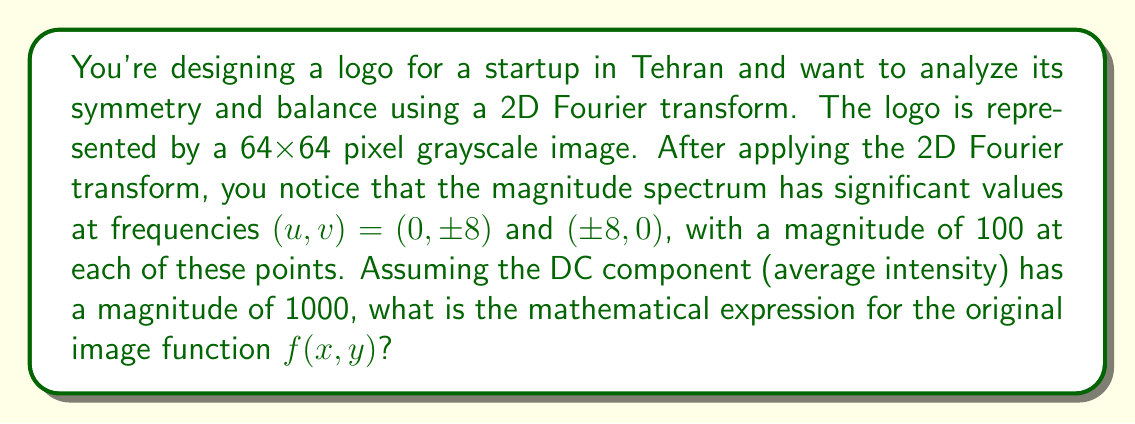Can you answer this question? To solve this problem, we need to work backwards from the Fourier transform to the original image function. Let's follow these steps:

1) The 2D Fourier transform pair is given by:

   $$F(u,v) = \sum_{x=0}^{M-1} \sum_{y=0}^{N-1} f(x,y) e^{-j2\pi(ux/M + vy/N)}$$
   $$f(x,y) = \frac{1}{MN} \sum_{u=0}^{M-1} \sum_{v=0}^{N-1} F(u,v) e^{j2\pi(ux/M + vy/N)}$$

   where M and N are the image dimensions (both 64 in this case).

2) From the given information, we know that:
   
   $F(0,0) = 1000$ (DC component)
   $F(0,\pm 8) = F(\pm 8,0) = 100$

3) The presence of symmetric components in the frequency domain indicates cosine terms in the spatial domain. The general form of a 2D cosine is:

   $$A \cos(2\pi(ux/M + vy/N))$$

4) For each frequency pair $(u,v)$, we need to add a cosine term with amplitude $A = F(u,v)/MN = 100/(64*64) = 0.0244140625$.

5) The DC component adds a constant term of $1000/(64*64) = 0.244140625$.

6) Combining all terms, we get:

   $$f(x,y) = 0.244140625 + 0.0244140625[\cos(2\pi(8x/64)) + \cos(2\pi(-8x/64)) + \cos(2\pi(8y/64)) + \cos(2\pi(-8y/64))]$$

7) Simplify using the cosine's even property $\cos(-\theta) = \cos(\theta)$:

   $$f(x,y) = 0.244140625 + 0.0488281250[\cos(2\pi(x/8)) + \cos(2\pi(y/8))]$$

This expression represents the original image function that would produce the given Fourier transform magnitude spectrum.
Answer: $$f(x,y) = 0.244140625 + 0.0488281250[\cos(2\pi(x/8)) + \cos(2\pi(y/8))]$$ 